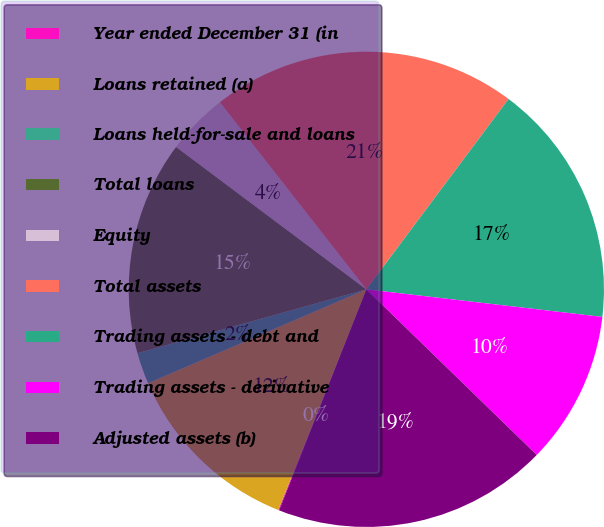Convert chart to OTSL. <chart><loc_0><loc_0><loc_500><loc_500><pie_chart><fcel>Year ended December 31 (in<fcel>Loans retained (a)<fcel>Loans held-for-sale and loans<fcel>Total loans<fcel>Equity<fcel>Total assets<fcel>Trading assets - debt and<fcel>Trading assets - derivative<fcel>Adjusted assets (b)<nl><fcel>0.06%<fcel>12.49%<fcel>2.13%<fcel>14.56%<fcel>4.2%<fcel>20.78%<fcel>16.64%<fcel>10.42%<fcel>18.71%<nl></chart> 